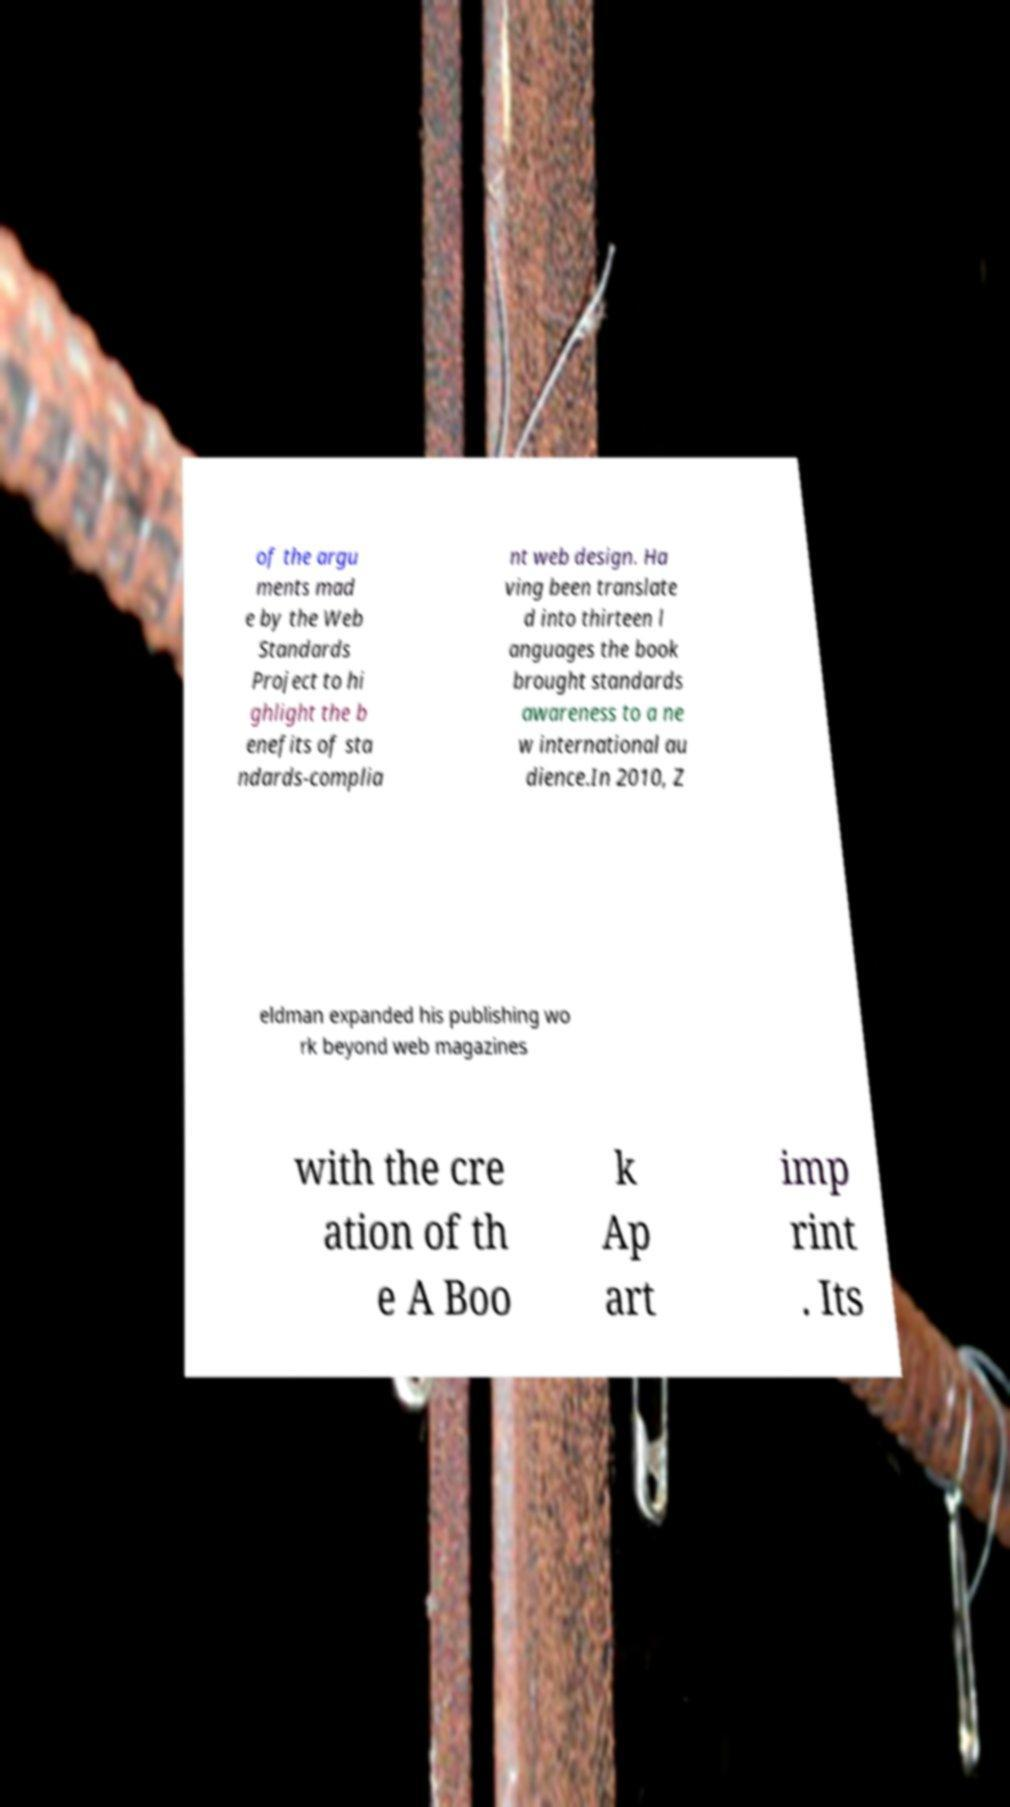There's text embedded in this image that I need extracted. Can you transcribe it verbatim? of the argu ments mad e by the Web Standards Project to hi ghlight the b enefits of sta ndards-complia nt web design. Ha ving been translate d into thirteen l anguages the book brought standards awareness to a ne w international au dience.In 2010, Z eldman expanded his publishing wo rk beyond web magazines with the cre ation of th e A Boo k Ap art imp rint . Its 